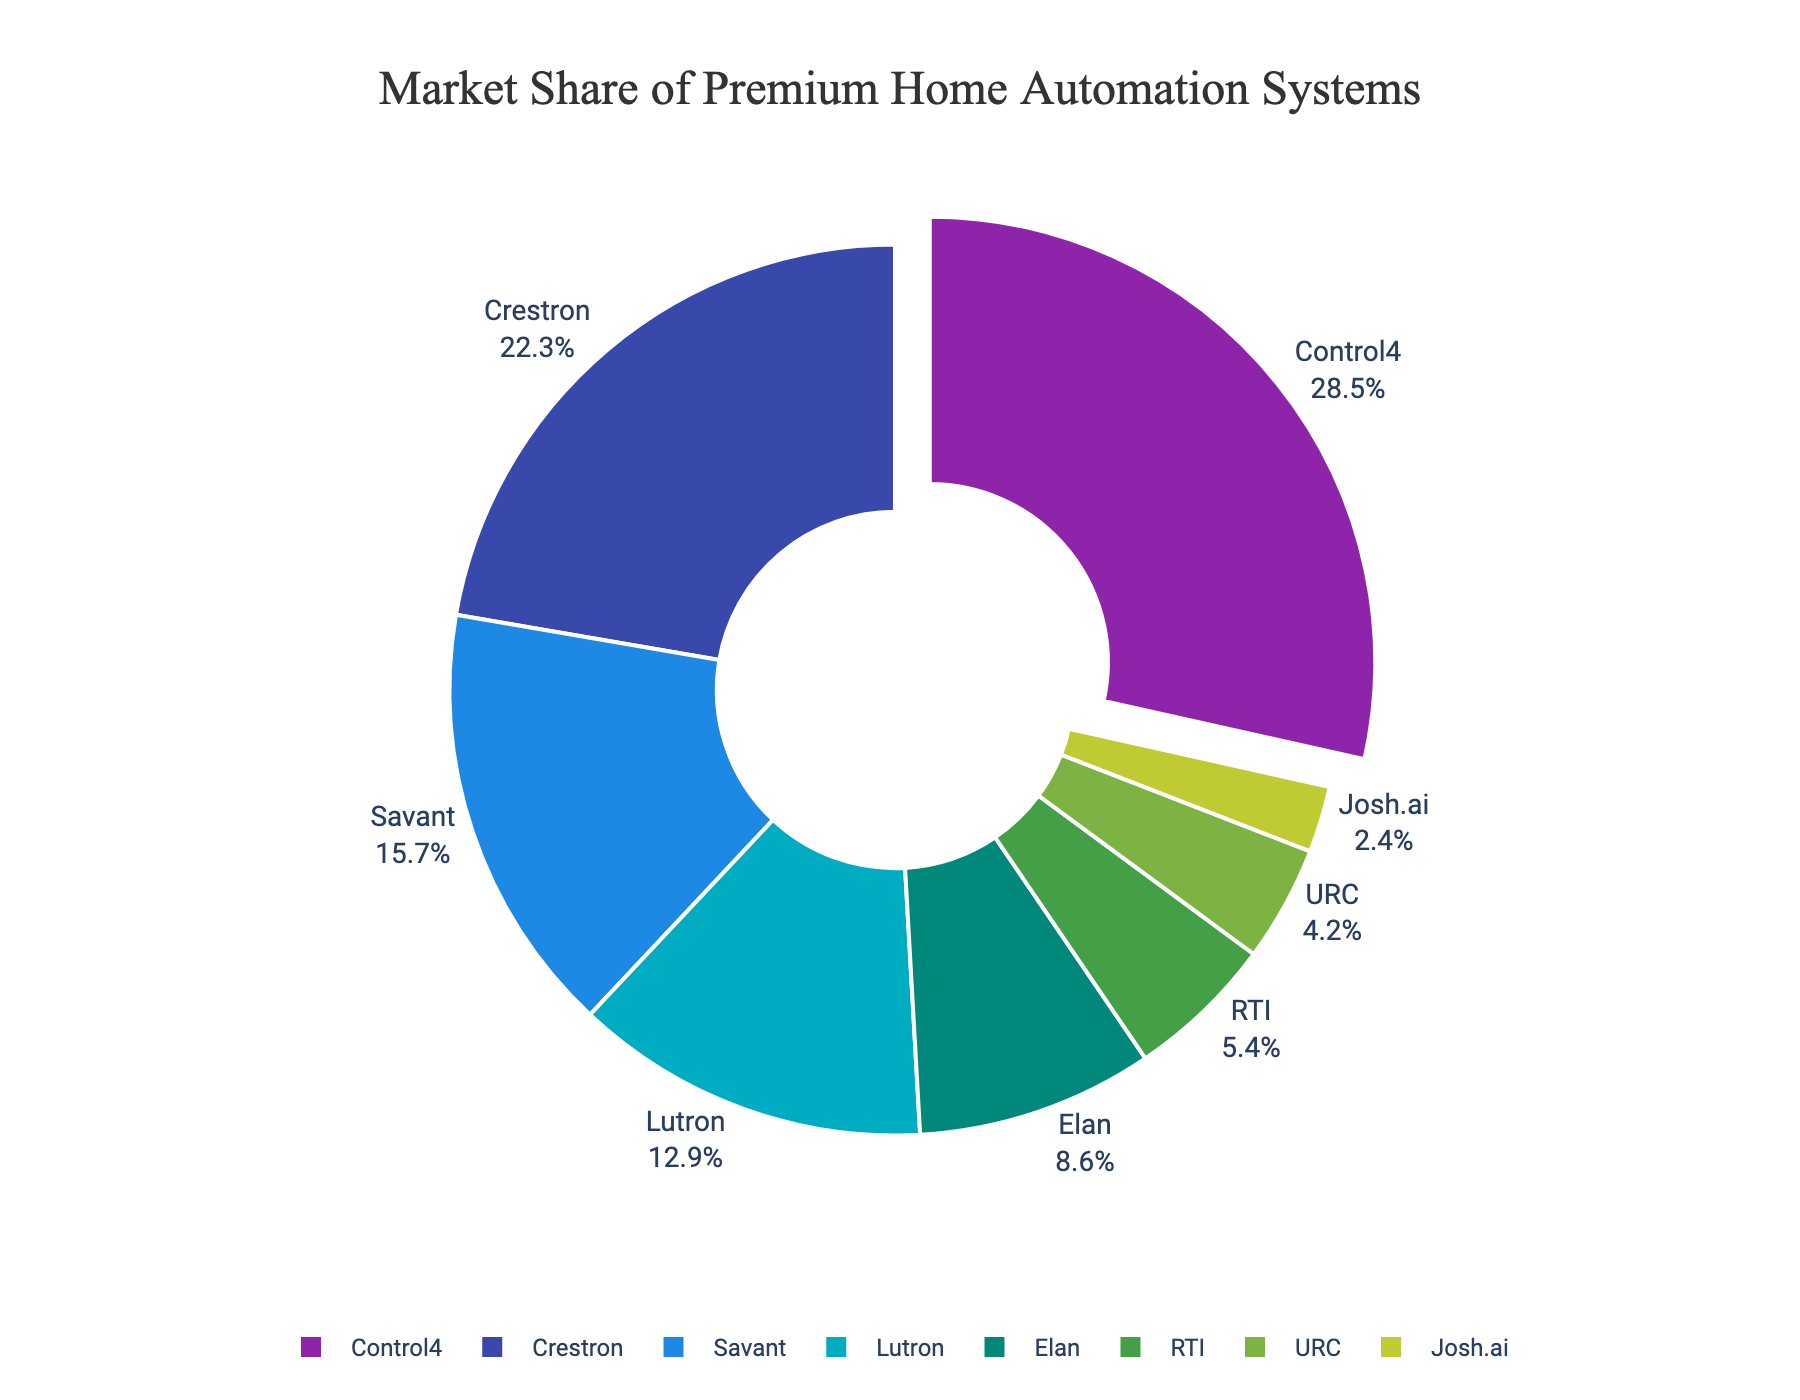What is the market share of the brand with the largest market share? The brand with the largest market share is highlighted by being slightly pulled out from the pie chart. By looking at the figure, Control4 is the largest section of the pie and is pulled out, showing a market share of 28.5%.
Answer: 28.5% Which two brands combined have a market share closest to 30%? We need to find two brands whose combined market share is close to 30%. Looking at the data visually, we see that Savant has 15.7% and Lutron has 12.9%. Summing these gives us 15.7% + 12.9% = 28.6%, which is closest to 30%.
Answer: Savant and Lutron Which brand has the smallest market share? The smallest portion of the pie chart represents the brand with the smallest market share. Josh.ai is the smallest section of the chart with a market share of 2.4%.
Answer: Josh.ai How much larger is the market share of Control4 compared to RTI? To find the market share difference between Control4 and RTI, subtract RTI's share from Control4's share: 28.5% - 5.4% = 23.1%.
Answer: 23.1% What is the combined market share of brands with a market share under 10%? We sum the market shares of the brands under 10%. These brands are Elan, RTI, URC, and Josh.ai. The combined market share is 8.6% + 5.4% + 4.2% + 2.4% = 20.6%.
Answer: 20.6% Which brand has a market share closest to the average market share of all brands? First, calculate the average market share by summing all shares and dividing by the number of brands. (28.5 + 22.3 + 15.7 + 12.9 + 8.6 + 5.4 + 4.2 + 2.4) / 8 = 12.5%. The brand closest to this average is Lutron at 12.9%.
Answer: Lutron Which two brands together have a larger market share, Crestron and Elan or Lutron and RTI? Calculate the combined market shares: Crestron and Elan have 22.3% + 8.6% = 30.9%, while Lutron and RTI have 12.9% + 5.4% = 18.3%.
Answer: Crestron and Elan What color represents the brand Savant in the pie chart? To identify the color representing Savant, look at the corresponding color in the legend and the pie slice. Savant is represented by a blue color.
Answer: Blue 